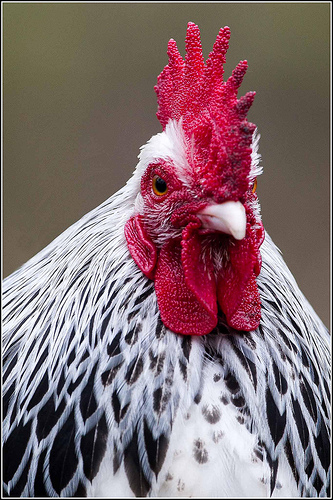<image>
Is there a crest above the beak? Yes. The crest is positioned above the beak in the vertical space, higher up in the scene. 